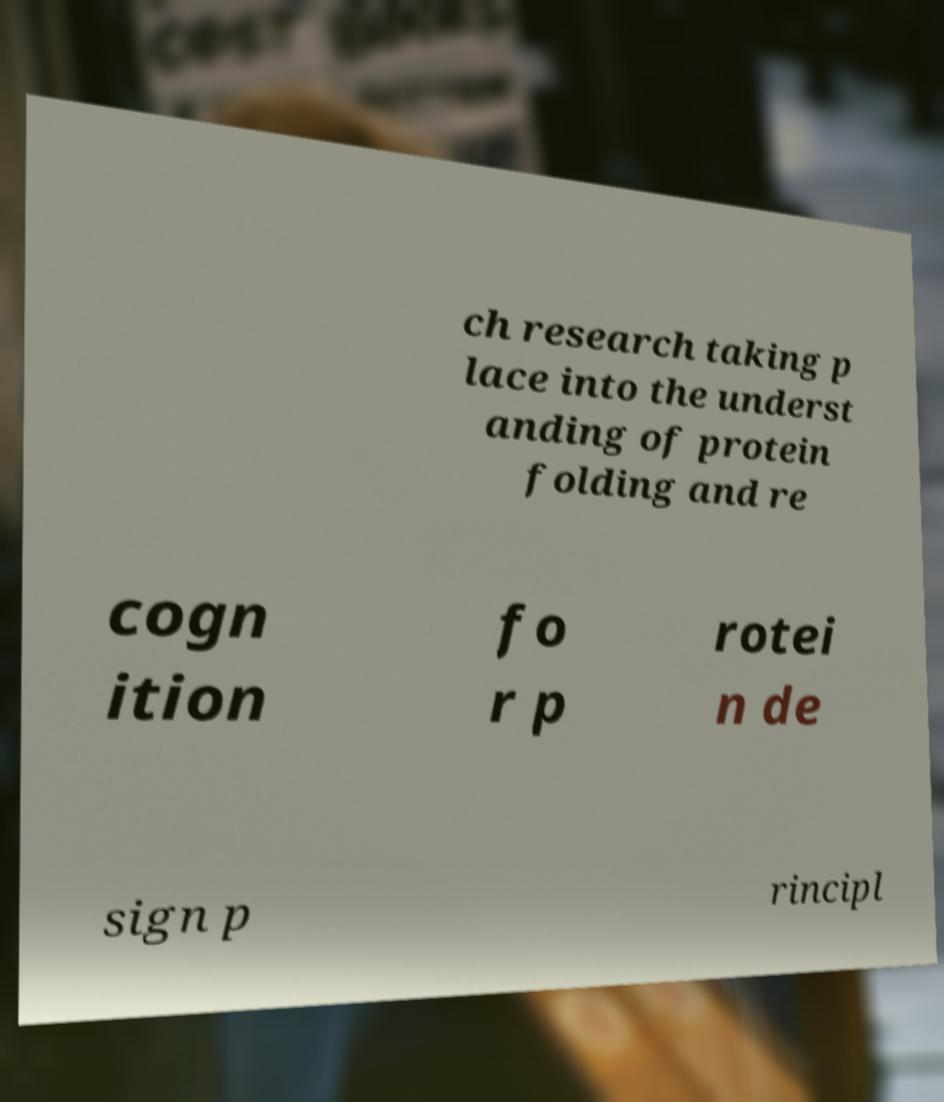For documentation purposes, I need the text within this image transcribed. Could you provide that? ch research taking p lace into the underst anding of protein folding and re cogn ition fo r p rotei n de sign p rincipl 